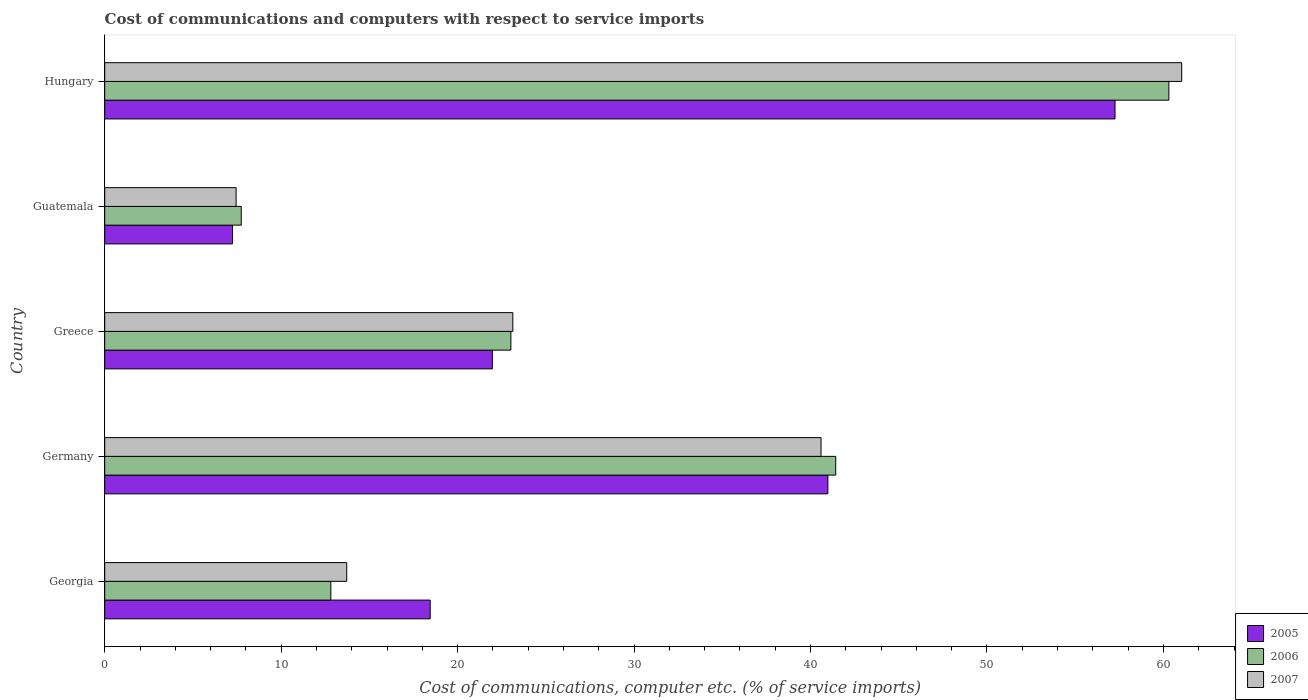How many groups of bars are there?
Your answer should be compact. 5. What is the label of the 4th group of bars from the top?
Provide a short and direct response. Germany. In how many cases, is the number of bars for a given country not equal to the number of legend labels?
Ensure brevity in your answer.  0. What is the cost of communications and computers in 2007 in Hungary?
Your answer should be compact. 61.04. Across all countries, what is the maximum cost of communications and computers in 2007?
Give a very brief answer. 61.04. Across all countries, what is the minimum cost of communications and computers in 2007?
Provide a short and direct response. 7.45. In which country was the cost of communications and computers in 2005 maximum?
Provide a succinct answer. Hungary. In which country was the cost of communications and computers in 2006 minimum?
Ensure brevity in your answer.  Guatemala. What is the total cost of communications and computers in 2007 in the graph?
Offer a very short reply. 145.92. What is the difference between the cost of communications and computers in 2007 in Georgia and that in Germany?
Offer a very short reply. -26.88. What is the difference between the cost of communications and computers in 2007 in Guatemala and the cost of communications and computers in 2006 in Georgia?
Offer a terse response. -5.37. What is the average cost of communications and computers in 2005 per country?
Your response must be concise. 29.18. What is the difference between the cost of communications and computers in 2007 and cost of communications and computers in 2005 in Georgia?
Give a very brief answer. -4.73. In how many countries, is the cost of communications and computers in 2005 greater than 8 %?
Your answer should be compact. 4. What is the ratio of the cost of communications and computers in 2007 in Greece to that in Hungary?
Give a very brief answer. 0.38. Is the cost of communications and computers in 2006 in Georgia less than that in Guatemala?
Your answer should be compact. No. What is the difference between the highest and the second highest cost of communications and computers in 2007?
Your response must be concise. 20.44. What is the difference between the highest and the lowest cost of communications and computers in 2007?
Keep it short and to the point. 53.59. Is the sum of the cost of communications and computers in 2006 in Georgia and Germany greater than the maximum cost of communications and computers in 2007 across all countries?
Keep it short and to the point. No. How many bars are there?
Offer a very short reply. 15. How many countries are there in the graph?
Offer a terse response. 5. What is the difference between two consecutive major ticks on the X-axis?
Offer a very short reply. 10. Are the values on the major ticks of X-axis written in scientific E-notation?
Give a very brief answer. No. Does the graph contain any zero values?
Provide a succinct answer. No. Does the graph contain grids?
Make the answer very short. No. Where does the legend appear in the graph?
Give a very brief answer. Bottom right. How many legend labels are there?
Make the answer very short. 3. How are the legend labels stacked?
Ensure brevity in your answer.  Vertical. What is the title of the graph?
Your answer should be very brief. Cost of communications and computers with respect to service imports. What is the label or title of the X-axis?
Your response must be concise. Cost of communications, computer etc. (% of service imports). What is the Cost of communications, computer etc. (% of service imports) of 2005 in Georgia?
Give a very brief answer. 18.45. What is the Cost of communications, computer etc. (% of service imports) in 2006 in Georgia?
Provide a succinct answer. 12.81. What is the Cost of communications, computer etc. (% of service imports) of 2007 in Georgia?
Offer a terse response. 13.71. What is the Cost of communications, computer etc. (% of service imports) in 2005 in Germany?
Provide a succinct answer. 40.98. What is the Cost of communications, computer etc. (% of service imports) of 2006 in Germany?
Make the answer very short. 41.43. What is the Cost of communications, computer etc. (% of service imports) in 2007 in Germany?
Offer a very short reply. 40.6. What is the Cost of communications, computer etc. (% of service imports) of 2005 in Greece?
Offer a terse response. 21.97. What is the Cost of communications, computer etc. (% of service imports) in 2006 in Greece?
Make the answer very short. 23.02. What is the Cost of communications, computer etc. (% of service imports) of 2007 in Greece?
Make the answer very short. 23.13. What is the Cost of communications, computer etc. (% of service imports) of 2005 in Guatemala?
Your answer should be compact. 7.24. What is the Cost of communications, computer etc. (% of service imports) in 2006 in Guatemala?
Offer a very short reply. 7.74. What is the Cost of communications, computer etc. (% of service imports) in 2007 in Guatemala?
Ensure brevity in your answer.  7.45. What is the Cost of communications, computer etc. (% of service imports) of 2005 in Hungary?
Keep it short and to the point. 57.26. What is the Cost of communications, computer etc. (% of service imports) of 2006 in Hungary?
Your answer should be very brief. 60.31. What is the Cost of communications, computer etc. (% of service imports) of 2007 in Hungary?
Offer a terse response. 61.04. Across all countries, what is the maximum Cost of communications, computer etc. (% of service imports) of 2005?
Offer a terse response. 57.26. Across all countries, what is the maximum Cost of communications, computer etc. (% of service imports) in 2006?
Offer a very short reply. 60.31. Across all countries, what is the maximum Cost of communications, computer etc. (% of service imports) of 2007?
Offer a terse response. 61.04. Across all countries, what is the minimum Cost of communications, computer etc. (% of service imports) in 2005?
Offer a terse response. 7.24. Across all countries, what is the minimum Cost of communications, computer etc. (% of service imports) in 2006?
Provide a succinct answer. 7.74. Across all countries, what is the minimum Cost of communications, computer etc. (% of service imports) in 2007?
Your answer should be compact. 7.45. What is the total Cost of communications, computer etc. (% of service imports) in 2005 in the graph?
Give a very brief answer. 145.9. What is the total Cost of communications, computer etc. (% of service imports) of 2006 in the graph?
Offer a terse response. 145.31. What is the total Cost of communications, computer etc. (% of service imports) in 2007 in the graph?
Your answer should be compact. 145.92. What is the difference between the Cost of communications, computer etc. (% of service imports) in 2005 in Georgia and that in Germany?
Offer a terse response. -22.54. What is the difference between the Cost of communications, computer etc. (% of service imports) in 2006 in Georgia and that in Germany?
Ensure brevity in your answer.  -28.61. What is the difference between the Cost of communications, computer etc. (% of service imports) in 2007 in Georgia and that in Germany?
Provide a succinct answer. -26.88. What is the difference between the Cost of communications, computer etc. (% of service imports) of 2005 in Georgia and that in Greece?
Your answer should be compact. -3.52. What is the difference between the Cost of communications, computer etc. (% of service imports) in 2006 in Georgia and that in Greece?
Keep it short and to the point. -10.2. What is the difference between the Cost of communications, computer etc. (% of service imports) in 2007 in Georgia and that in Greece?
Offer a terse response. -9.41. What is the difference between the Cost of communications, computer etc. (% of service imports) in 2005 in Georgia and that in Guatemala?
Your answer should be very brief. 11.2. What is the difference between the Cost of communications, computer etc. (% of service imports) of 2006 in Georgia and that in Guatemala?
Ensure brevity in your answer.  5.08. What is the difference between the Cost of communications, computer etc. (% of service imports) in 2007 in Georgia and that in Guatemala?
Provide a succinct answer. 6.27. What is the difference between the Cost of communications, computer etc. (% of service imports) of 2005 in Georgia and that in Hungary?
Give a very brief answer. -38.81. What is the difference between the Cost of communications, computer etc. (% of service imports) of 2006 in Georgia and that in Hungary?
Your answer should be compact. -47.49. What is the difference between the Cost of communications, computer etc. (% of service imports) in 2007 in Georgia and that in Hungary?
Ensure brevity in your answer.  -47.32. What is the difference between the Cost of communications, computer etc. (% of service imports) in 2005 in Germany and that in Greece?
Make the answer very short. 19.02. What is the difference between the Cost of communications, computer etc. (% of service imports) of 2006 in Germany and that in Greece?
Your response must be concise. 18.41. What is the difference between the Cost of communications, computer etc. (% of service imports) in 2007 in Germany and that in Greece?
Ensure brevity in your answer.  17.47. What is the difference between the Cost of communications, computer etc. (% of service imports) in 2005 in Germany and that in Guatemala?
Your answer should be very brief. 33.74. What is the difference between the Cost of communications, computer etc. (% of service imports) of 2006 in Germany and that in Guatemala?
Provide a short and direct response. 33.69. What is the difference between the Cost of communications, computer etc. (% of service imports) of 2007 in Germany and that in Guatemala?
Offer a very short reply. 33.15. What is the difference between the Cost of communications, computer etc. (% of service imports) of 2005 in Germany and that in Hungary?
Offer a very short reply. -16.27. What is the difference between the Cost of communications, computer etc. (% of service imports) of 2006 in Germany and that in Hungary?
Offer a terse response. -18.88. What is the difference between the Cost of communications, computer etc. (% of service imports) in 2007 in Germany and that in Hungary?
Your response must be concise. -20.44. What is the difference between the Cost of communications, computer etc. (% of service imports) of 2005 in Greece and that in Guatemala?
Ensure brevity in your answer.  14.72. What is the difference between the Cost of communications, computer etc. (% of service imports) in 2006 in Greece and that in Guatemala?
Keep it short and to the point. 15.28. What is the difference between the Cost of communications, computer etc. (% of service imports) in 2007 in Greece and that in Guatemala?
Your answer should be very brief. 15.68. What is the difference between the Cost of communications, computer etc. (% of service imports) of 2005 in Greece and that in Hungary?
Offer a terse response. -35.29. What is the difference between the Cost of communications, computer etc. (% of service imports) in 2006 in Greece and that in Hungary?
Ensure brevity in your answer.  -37.29. What is the difference between the Cost of communications, computer etc. (% of service imports) in 2007 in Greece and that in Hungary?
Make the answer very short. -37.91. What is the difference between the Cost of communications, computer etc. (% of service imports) of 2005 in Guatemala and that in Hungary?
Make the answer very short. -50.01. What is the difference between the Cost of communications, computer etc. (% of service imports) in 2006 in Guatemala and that in Hungary?
Offer a terse response. -52.57. What is the difference between the Cost of communications, computer etc. (% of service imports) in 2007 in Guatemala and that in Hungary?
Provide a succinct answer. -53.59. What is the difference between the Cost of communications, computer etc. (% of service imports) of 2005 in Georgia and the Cost of communications, computer etc. (% of service imports) of 2006 in Germany?
Offer a very short reply. -22.98. What is the difference between the Cost of communications, computer etc. (% of service imports) of 2005 in Georgia and the Cost of communications, computer etc. (% of service imports) of 2007 in Germany?
Offer a terse response. -22.15. What is the difference between the Cost of communications, computer etc. (% of service imports) of 2006 in Georgia and the Cost of communications, computer etc. (% of service imports) of 2007 in Germany?
Keep it short and to the point. -27.78. What is the difference between the Cost of communications, computer etc. (% of service imports) of 2005 in Georgia and the Cost of communications, computer etc. (% of service imports) of 2006 in Greece?
Provide a short and direct response. -4.57. What is the difference between the Cost of communications, computer etc. (% of service imports) of 2005 in Georgia and the Cost of communications, computer etc. (% of service imports) of 2007 in Greece?
Give a very brief answer. -4.68. What is the difference between the Cost of communications, computer etc. (% of service imports) in 2006 in Georgia and the Cost of communications, computer etc. (% of service imports) in 2007 in Greece?
Give a very brief answer. -10.31. What is the difference between the Cost of communications, computer etc. (% of service imports) in 2005 in Georgia and the Cost of communications, computer etc. (% of service imports) in 2006 in Guatemala?
Keep it short and to the point. 10.71. What is the difference between the Cost of communications, computer etc. (% of service imports) in 2005 in Georgia and the Cost of communications, computer etc. (% of service imports) in 2007 in Guatemala?
Provide a succinct answer. 11. What is the difference between the Cost of communications, computer etc. (% of service imports) in 2006 in Georgia and the Cost of communications, computer etc. (% of service imports) in 2007 in Guatemala?
Provide a succinct answer. 5.37. What is the difference between the Cost of communications, computer etc. (% of service imports) of 2005 in Georgia and the Cost of communications, computer etc. (% of service imports) of 2006 in Hungary?
Offer a terse response. -41.86. What is the difference between the Cost of communications, computer etc. (% of service imports) in 2005 in Georgia and the Cost of communications, computer etc. (% of service imports) in 2007 in Hungary?
Your answer should be very brief. -42.59. What is the difference between the Cost of communications, computer etc. (% of service imports) in 2006 in Georgia and the Cost of communications, computer etc. (% of service imports) in 2007 in Hungary?
Your answer should be very brief. -48.22. What is the difference between the Cost of communications, computer etc. (% of service imports) in 2005 in Germany and the Cost of communications, computer etc. (% of service imports) in 2006 in Greece?
Your response must be concise. 17.97. What is the difference between the Cost of communications, computer etc. (% of service imports) of 2005 in Germany and the Cost of communications, computer etc. (% of service imports) of 2007 in Greece?
Offer a very short reply. 17.86. What is the difference between the Cost of communications, computer etc. (% of service imports) in 2006 in Germany and the Cost of communications, computer etc. (% of service imports) in 2007 in Greece?
Provide a short and direct response. 18.3. What is the difference between the Cost of communications, computer etc. (% of service imports) in 2005 in Germany and the Cost of communications, computer etc. (% of service imports) in 2006 in Guatemala?
Your answer should be compact. 33.25. What is the difference between the Cost of communications, computer etc. (% of service imports) in 2005 in Germany and the Cost of communications, computer etc. (% of service imports) in 2007 in Guatemala?
Provide a short and direct response. 33.54. What is the difference between the Cost of communications, computer etc. (% of service imports) of 2006 in Germany and the Cost of communications, computer etc. (% of service imports) of 2007 in Guatemala?
Your answer should be compact. 33.98. What is the difference between the Cost of communications, computer etc. (% of service imports) of 2005 in Germany and the Cost of communications, computer etc. (% of service imports) of 2006 in Hungary?
Offer a very short reply. -19.32. What is the difference between the Cost of communications, computer etc. (% of service imports) of 2005 in Germany and the Cost of communications, computer etc. (% of service imports) of 2007 in Hungary?
Your answer should be very brief. -20.05. What is the difference between the Cost of communications, computer etc. (% of service imports) in 2006 in Germany and the Cost of communications, computer etc. (% of service imports) in 2007 in Hungary?
Offer a terse response. -19.61. What is the difference between the Cost of communications, computer etc. (% of service imports) in 2005 in Greece and the Cost of communications, computer etc. (% of service imports) in 2006 in Guatemala?
Ensure brevity in your answer.  14.23. What is the difference between the Cost of communications, computer etc. (% of service imports) of 2005 in Greece and the Cost of communications, computer etc. (% of service imports) of 2007 in Guatemala?
Your answer should be very brief. 14.52. What is the difference between the Cost of communications, computer etc. (% of service imports) of 2006 in Greece and the Cost of communications, computer etc. (% of service imports) of 2007 in Guatemala?
Your answer should be very brief. 15.57. What is the difference between the Cost of communications, computer etc. (% of service imports) in 2005 in Greece and the Cost of communications, computer etc. (% of service imports) in 2006 in Hungary?
Offer a terse response. -38.34. What is the difference between the Cost of communications, computer etc. (% of service imports) of 2005 in Greece and the Cost of communications, computer etc. (% of service imports) of 2007 in Hungary?
Give a very brief answer. -39.07. What is the difference between the Cost of communications, computer etc. (% of service imports) of 2006 in Greece and the Cost of communications, computer etc. (% of service imports) of 2007 in Hungary?
Your answer should be compact. -38.02. What is the difference between the Cost of communications, computer etc. (% of service imports) of 2005 in Guatemala and the Cost of communications, computer etc. (% of service imports) of 2006 in Hungary?
Provide a succinct answer. -53.07. What is the difference between the Cost of communications, computer etc. (% of service imports) in 2005 in Guatemala and the Cost of communications, computer etc. (% of service imports) in 2007 in Hungary?
Provide a short and direct response. -53.79. What is the difference between the Cost of communications, computer etc. (% of service imports) in 2006 in Guatemala and the Cost of communications, computer etc. (% of service imports) in 2007 in Hungary?
Give a very brief answer. -53.3. What is the average Cost of communications, computer etc. (% of service imports) in 2005 per country?
Provide a short and direct response. 29.18. What is the average Cost of communications, computer etc. (% of service imports) of 2006 per country?
Offer a terse response. 29.06. What is the average Cost of communications, computer etc. (% of service imports) of 2007 per country?
Provide a succinct answer. 29.18. What is the difference between the Cost of communications, computer etc. (% of service imports) of 2005 and Cost of communications, computer etc. (% of service imports) of 2006 in Georgia?
Provide a short and direct response. 5.63. What is the difference between the Cost of communications, computer etc. (% of service imports) of 2005 and Cost of communications, computer etc. (% of service imports) of 2007 in Georgia?
Keep it short and to the point. 4.73. What is the difference between the Cost of communications, computer etc. (% of service imports) of 2006 and Cost of communications, computer etc. (% of service imports) of 2007 in Georgia?
Your answer should be compact. -0.9. What is the difference between the Cost of communications, computer etc. (% of service imports) in 2005 and Cost of communications, computer etc. (% of service imports) in 2006 in Germany?
Offer a terse response. -0.44. What is the difference between the Cost of communications, computer etc. (% of service imports) in 2005 and Cost of communications, computer etc. (% of service imports) in 2007 in Germany?
Give a very brief answer. 0.39. What is the difference between the Cost of communications, computer etc. (% of service imports) of 2006 and Cost of communications, computer etc. (% of service imports) of 2007 in Germany?
Keep it short and to the point. 0.83. What is the difference between the Cost of communications, computer etc. (% of service imports) of 2005 and Cost of communications, computer etc. (% of service imports) of 2006 in Greece?
Offer a very short reply. -1.05. What is the difference between the Cost of communications, computer etc. (% of service imports) in 2005 and Cost of communications, computer etc. (% of service imports) in 2007 in Greece?
Your answer should be very brief. -1.16. What is the difference between the Cost of communications, computer etc. (% of service imports) of 2006 and Cost of communications, computer etc. (% of service imports) of 2007 in Greece?
Your response must be concise. -0.11. What is the difference between the Cost of communications, computer etc. (% of service imports) of 2005 and Cost of communications, computer etc. (% of service imports) of 2006 in Guatemala?
Your answer should be very brief. -0.49. What is the difference between the Cost of communications, computer etc. (% of service imports) of 2005 and Cost of communications, computer etc. (% of service imports) of 2007 in Guatemala?
Offer a terse response. -0.2. What is the difference between the Cost of communications, computer etc. (% of service imports) of 2006 and Cost of communications, computer etc. (% of service imports) of 2007 in Guatemala?
Your answer should be compact. 0.29. What is the difference between the Cost of communications, computer etc. (% of service imports) of 2005 and Cost of communications, computer etc. (% of service imports) of 2006 in Hungary?
Provide a succinct answer. -3.05. What is the difference between the Cost of communications, computer etc. (% of service imports) of 2005 and Cost of communications, computer etc. (% of service imports) of 2007 in Hungary?
Make the answer very short. -3.78. What is the difference between the Cost of communications, computer etc. (% of service imports) in 2006 and Cost of communications, computer etc. (% of service imports) in 2007 in Hungary?
Your answer should be compact. -0.73. What is the ratio of the Cost of communications, computer etc. (% of service imports) in 2005 in Georgia to that in Germany?
Ensure brevity in your answer.  0.45. What is the ratio of the Cost of communications, computer etc. (% of service imports) in 2006 in Georgia to that in Germany?
Offer a very short reply. 0.31. What is the ratio of the Cost of communications, computer etc. (% of service imports) in 2007 in Georgia to that in Germany?
Provide a succinct answer. 0.34. What is the ratio of the Cost of communications, computer etc. (% of service imports) in 2005 in Georgia to that in Greece?
Make the answer very short. 0.84. What is the ratio of the Cost of communications, computer etc. (% of service imports) in 2006 in Georgia to that in Greece?
Ensure brevity in your answer.  0.56. What is the ratio of the Cost of communications, computer etc. (% of service imports) of 2007 in Georgia to that in Greece?
Ensure brevity in your answer.  0.59. What is the ratio of the Cost of communications, computer etc. (% of service imports) of 2005 in Georgia to that in Guatemala?
Make the answer very short. 2.55. What is the ratio of the Cost of communications, computer etc. (% of service imports) in 2006 in Georgia to that in Guatemala?
Give a very brief answer. 1.66. What is the ratio of the Cost of communications, computer etc. (% of service imports) of 2007 in Georgia to that in Guatemala?
Keep it short and to the point. 1.84. What is the ratio of the Cost of communications, computer etc. (% of service imports) of 2005 in Georgia to that in Hungary?
Make the answer very short. 0.32. What is the ratio of the Cost of communications, computer etc. (% of service imports) of 2006 in Georgia to that in Hungary?
Make the answer very short. 0.21. What is the ratio of the Cost of communications, computer etc. (% of service imports) of 2007 in Georgia to that in Hungary?
Your answer should be very brief. 0.22. What is the ratio of the Cost of communications, computer etc. (% of service imports) of 2005 in Germany to that in Greece?
Make the answer very short. 1.87. What is the ratio of the Cost of communications, computer etc. (% of service imports) in 2006 in Germany to that in Greece?
Your response must be concise. 1.8. What is the ratio of the Cost of communications, computer etc. (% of service imports) of 2007 in Germany to that in Greece?
Give a very brief answer. 1.76. What is the ratio of the Cost of communications, computer etc. (% of service imports) of 2005 in Germany to that in Guatemala?
Offer a very short reply. 5.66. What is the ratio of the Cost of communications, computer etc. (% of service imports) in 2006 in Germany to that in Guatemala?
Your response must be concise. 5.35. What is the ratio of the Cost of communications, computer etc. (% of service imports) in 2007 in Germany to that in Guatemala?
Your answer should be very brief. 5.45. What is the ratio of the Cost of communications, computer etc. (% of service imports) of 2005 in Germany to that in Hungary?
Your answer should be compact. 0.72. What is the ratio of the Cost of communications, computer etc. (% of service imports) of 2006 in Germany to that in Hungary?
Give a very brief answer. 0.69. What is the ratio of the Cost of communications, computer etc. (% of service imports) of 2007 in Germany to that in Hungary?
Keep it short and to the point. 0.67. What is the ratio of the Cost of communications, computer etc. (% of service imports) of 2005 in Greece to that in Guatemala?
Offer a very short reply. 3.03. What is the ratio of the Cost of communications, computer etc. (% of service imports) in 2006 in Greece to that in Guatemala?
Your answer should be very brief. 2.97. What is the ratio of the Cost of communications, computer etc. (% of service imports) in 2007 in Greece to that in Guatemala?
Give a very brief answer. 3.11. What is the ratio of the Cost of communications, computer etc. (% of service imports) of 2005 in Greece to that in Hungary?
Provide a short and direct response. 0.38. What is the ratio of the Cost of communications, computer etc. (% of service imports) in 2006 in Greece to that in Hungary?
Keep it short and to the point. 0.38. What is the ratio of the Cost of communications, computer etc. (% of service imports) in 2007 in Greece to that in Hungary?
Offer a terse response. 0.38. What is the ratio of the Cost of communications, computer etc. (% of service imports) in 2005 in Guatemala to that in Hungary?
Give a very brief answer. 0.13. What is the ratio of the Cost of communications, computer etc. (% of service imports) of 2006 in Guatemala to that in Hungary?
Your response must be concise. 0.13. What is the ratio of the Cost of communications, computer etc. (% of service imports) in 2007 in Guatemala to that in Hungary?
Offer a terse response. 0.12. What is the difference between the highest and the second highest Cost of communications, computer etc. (% of service imports) in 2005?
Give a very brief answer. 16.27. What is the difference between the highest and the second highest Cost of communications, computer etc. (% of service imports) of 2006?
Your response must be concise. 18.88. What is the difference between the highest and the second highest Cost of communications, computer etc. (% of service imports) in 2007?
Your response must be concise. 20.44. What is the difference between the highest and the lowest Cost of communications, computer etc. (% of service imports) in 2005?
Offer a terse response. 50.01. What is the difference between the highest and the lowest Cost of communications, computer etc. (% of service imports) in 2006?
Your answer should be compact. 52.57. What is the difference between the highest and the lowest Cost of communications, computer etc. (% of service imports) in 2007?
Your response must be concise. 53.59. 